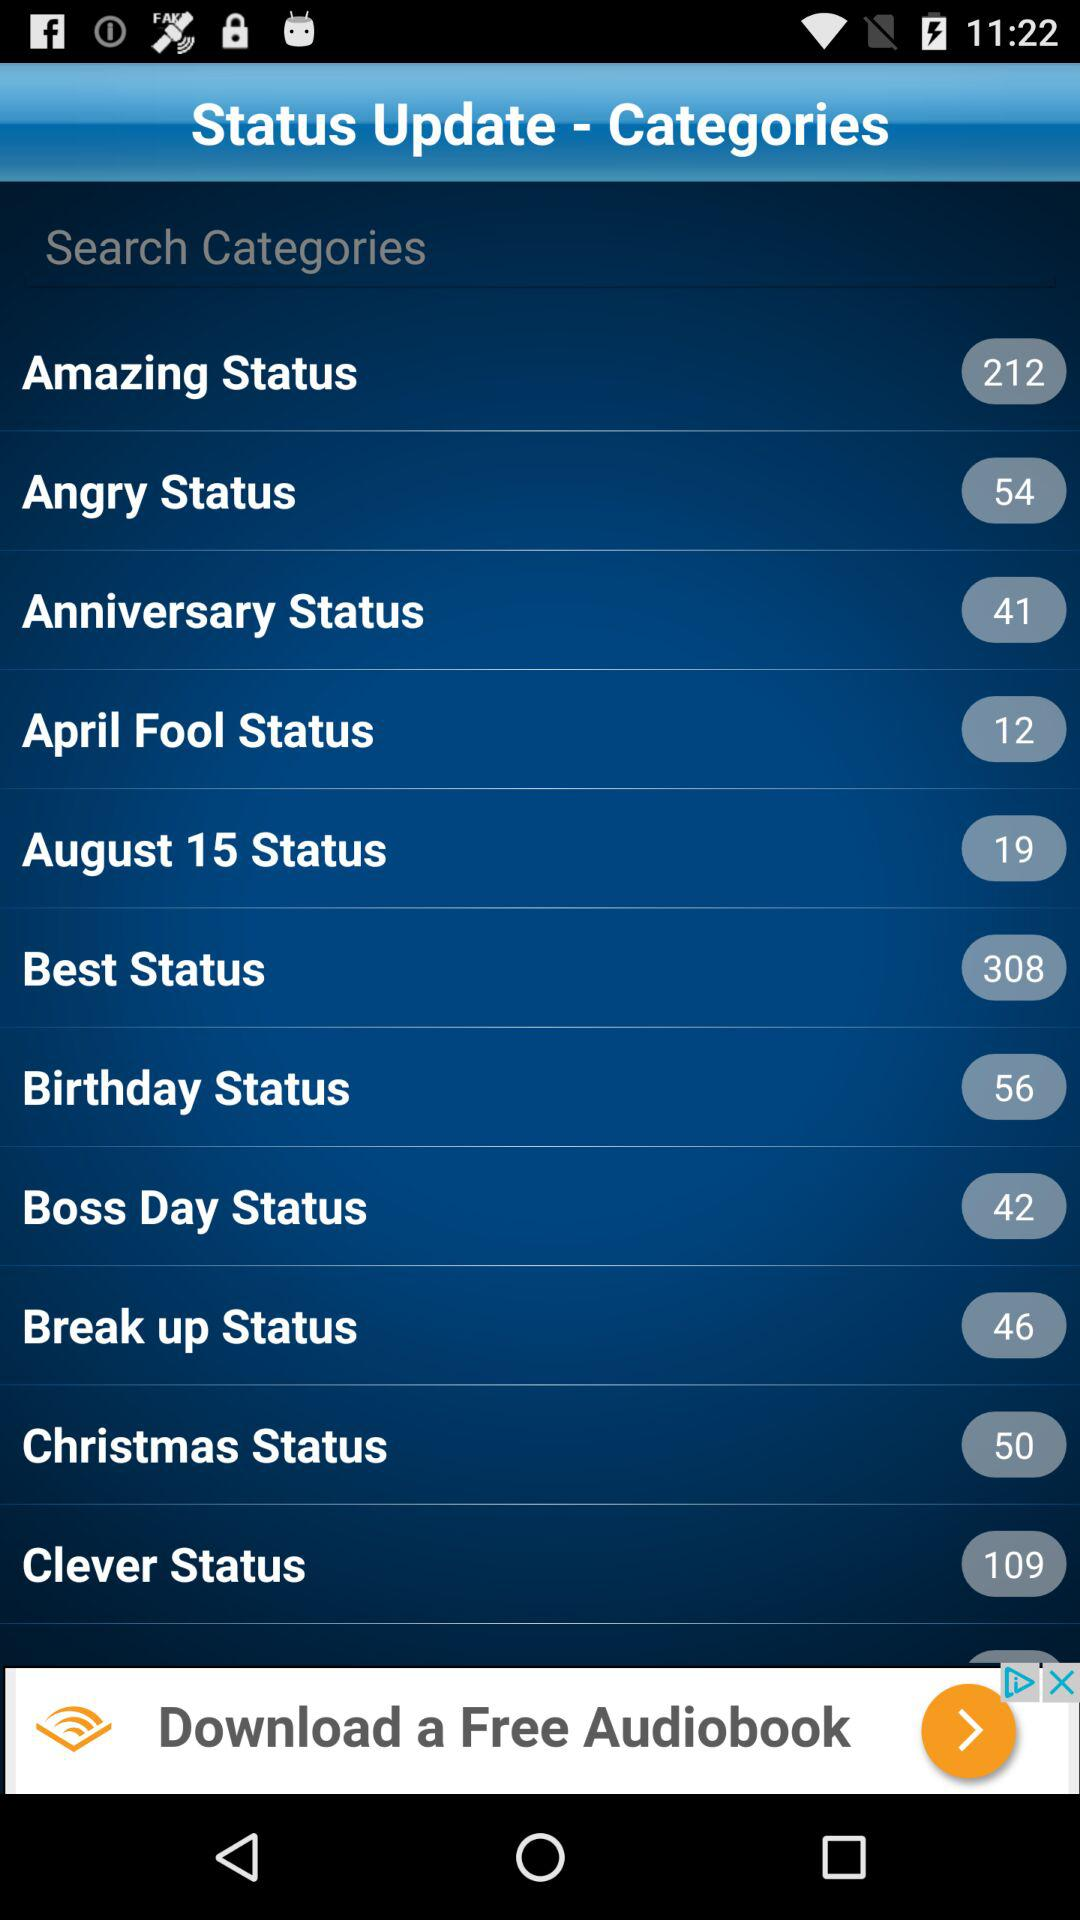What is the number of "Birthday Status"? The number is 56. 